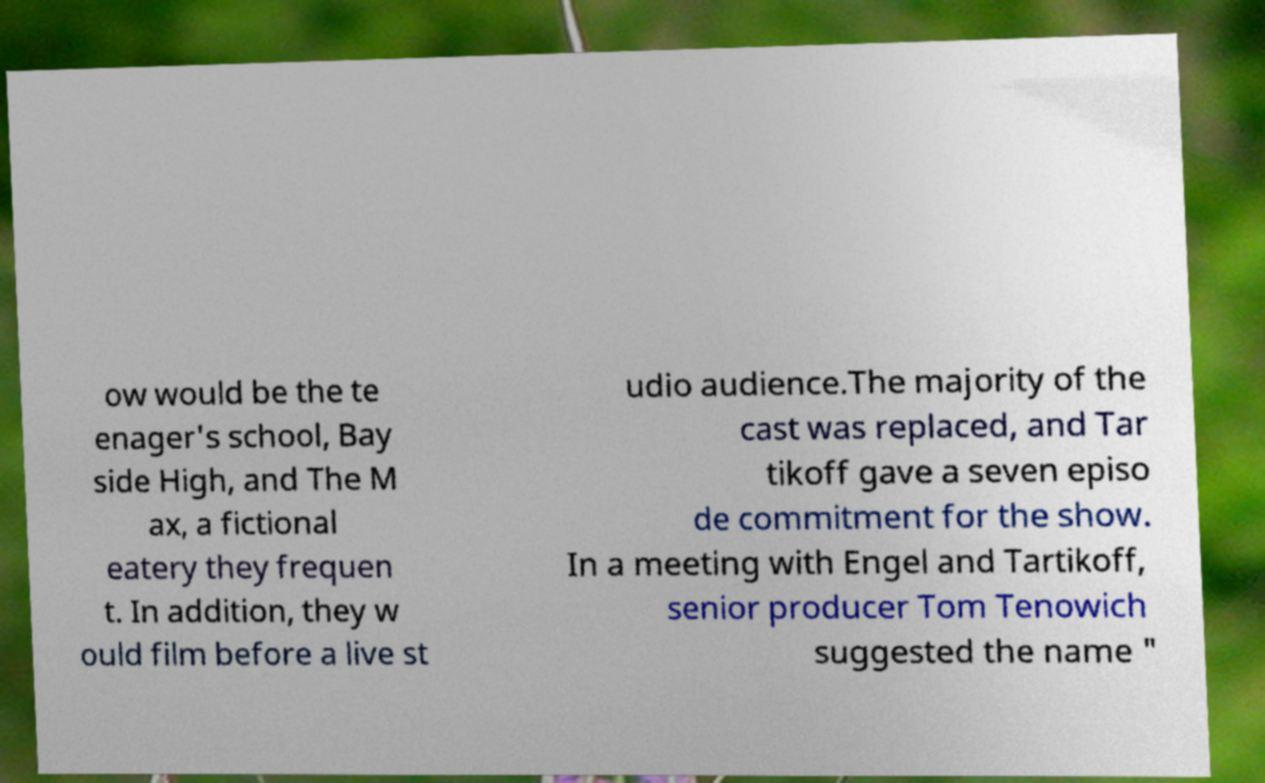Please read and relay the text visible in this image. What does it say? ow would be the te enager's school, Bay side High, and The M ax, a fictional eatery they frequen t. In addition, they w ould film before a live st udio audience.The majority of the cast was replaced, and Tar tikoff gave a seven episo de commitment for the show. In a meeting with Engel and Tartikoff, senior producer Tom Tenowich suggested the name " 